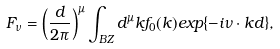Convert formula to latex. <formula><loc_0><loc_0><loc_500><loc_500>F _ { \nu } = \left ( { \frac { d } { 2 \pi } } \right ) ^ { \mu } \int _ { B Z } d ^ { \mu } k f _ { 0 } ( { k } ) e x p \{ - i { \nu \cdot k } d { \} , }</formula> 